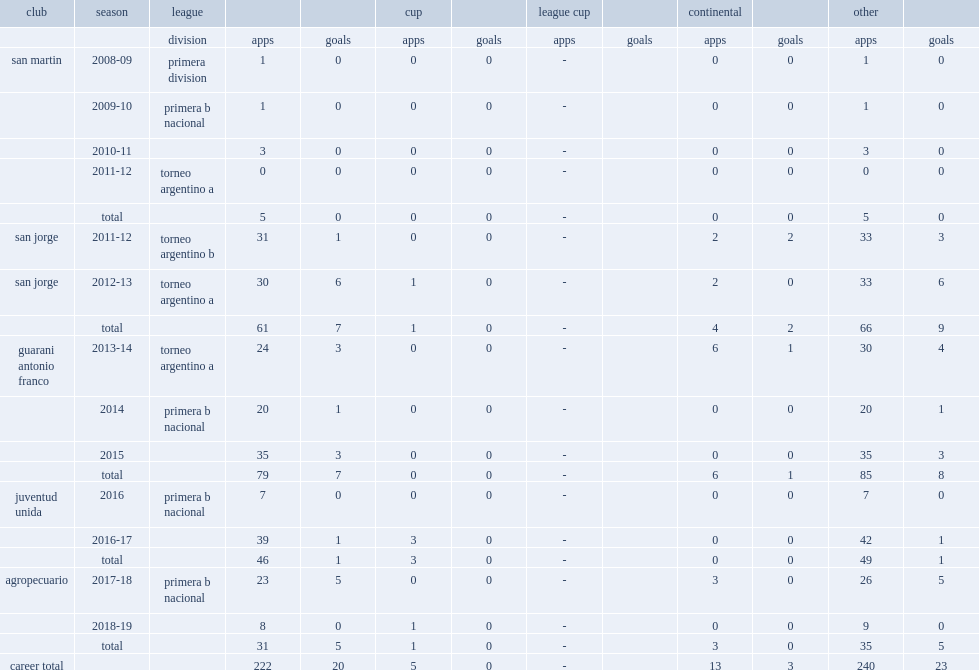In 2016, which club did narese join and remain with the club for two seasons? Juventud unida. 